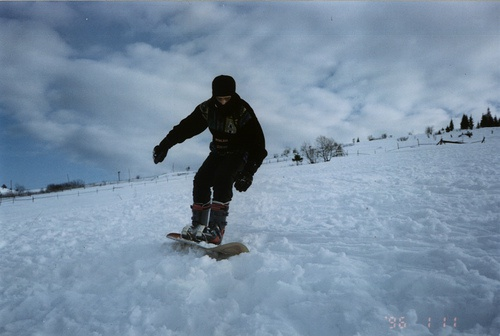Describe the objects in this image and their specific colors. I can see people in darkgray, black, gray, and maroon tones and snowboard in darkgray, gray, and black tones in this image. 